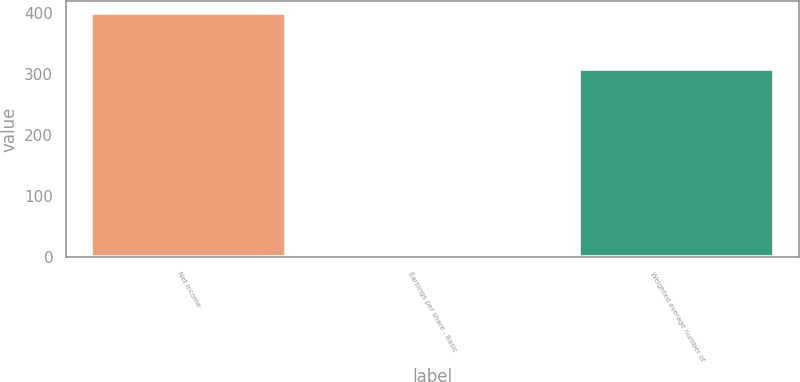Convert chart. <chart><loc_0><loc_0><loc_500><loc_500><bar_chart><fcel>Net income<fcel>Earnings per share - Basic<fcel>Weighted average number of<nl><fcel>399<fcel>1.3<fcel>307.57<nl></chart> 